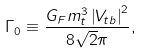<formula> <loc_0><loc_0><loc_500><loc_500>\Gamma _ { 0 } \equiv \frac { G _ { F } m _ { t } ^ { 3 } \left | V _ { t b } \right | ^ { 2 } } { 8 \sqrt { 2 } \pi } ,</formula> 